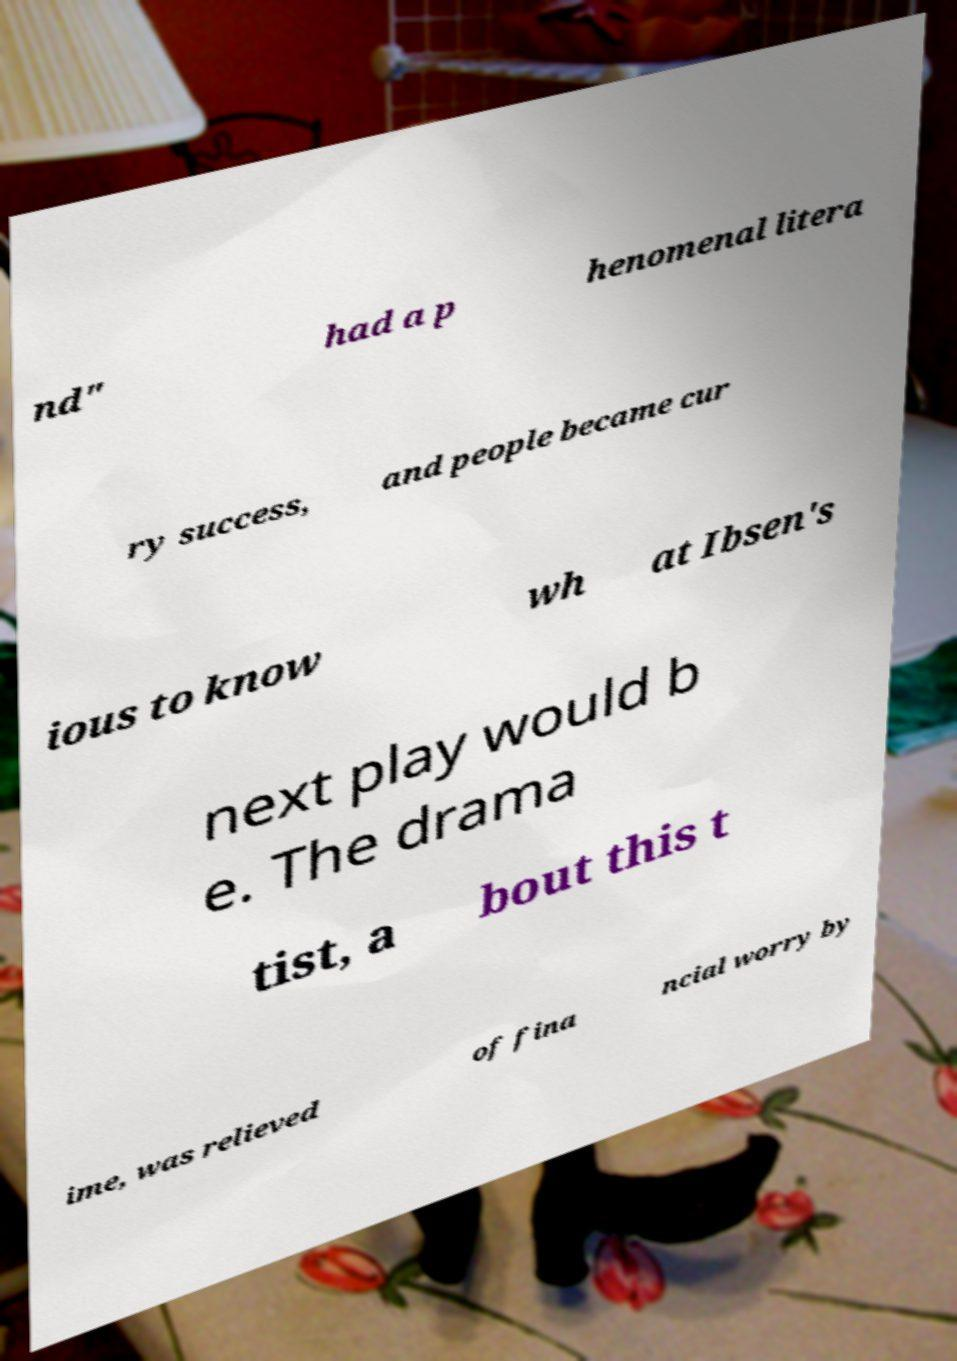What messages or text are displayed in this image? I need them in a readable, typed format. nd" had a p henomenal litera ry success, and people became cur ious to know wh at Ibsen's next play would b e. The drama tist, a bout this t ime, was relieved of fina ncial worry by 